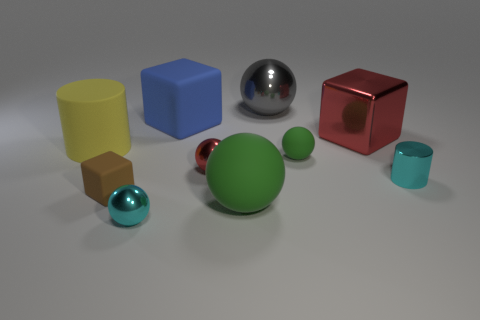Subtract all cyan metallic spheres. How many spheres are left? 4 Subtract 2 blocks. How many blocks are left? 1 Subtract all green balls. How many balls are left? 3 Subtract 1 red cubes. How many objects are left? 9 Subtract all cylinders. How many objects are left? 8 Subtract all blue cubes. Subtract all red spheres. How many cubes are left? 2 Subtract all green spheres. How many yellow cylinders are left? 1 Subtract all green spheres. Subtract all small brown rubber cubes. How many objects are left? 7 Add 8 shiny cylinders. How many shiny cylinders are left? 9 Add 2 large green metallic balls. How many large green metallic balls exist? 2 